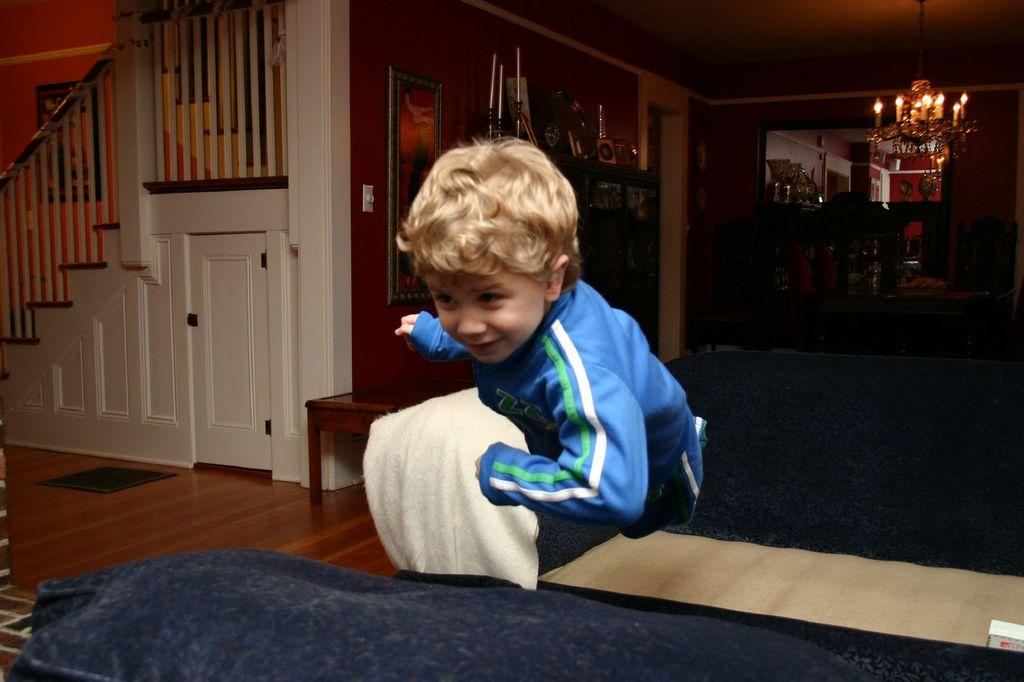Who is the main subject in the image? There is a boy in the image. What is the boy doing in the image? The boy is running on the floor. What furniture is present in the image? There is a couch and a shelf in the image. What type of lamp is visible in the image? There is a lightning lamp in the image. How many kittens are playing with the lightning lamp in the image? There are no kittens present in the image, and therefore they cannot be playing with the lightning lamp. 